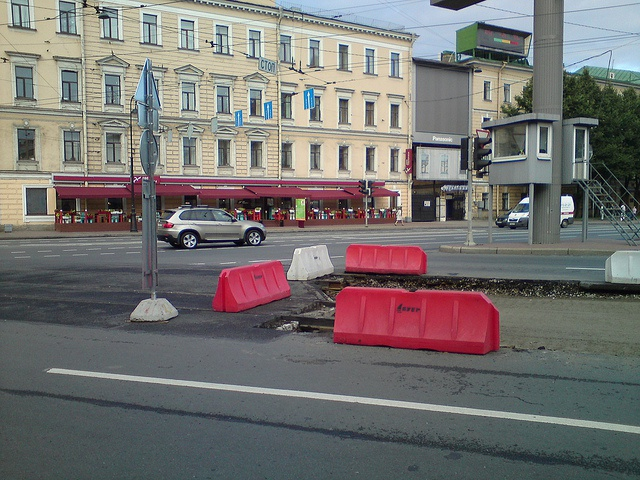Describe the objects in this image and their specific colors. I can see car in tan, gray, black, darkgray, and beige tones, truck in tan, ivory, gray, black, and navy tones, traffic light in tan, black, gray, navy, and blue tones, traffic light in tan, black, navy, gray, and blue tones, and car in tan, black, gray, navy, and blue tones in this image. 